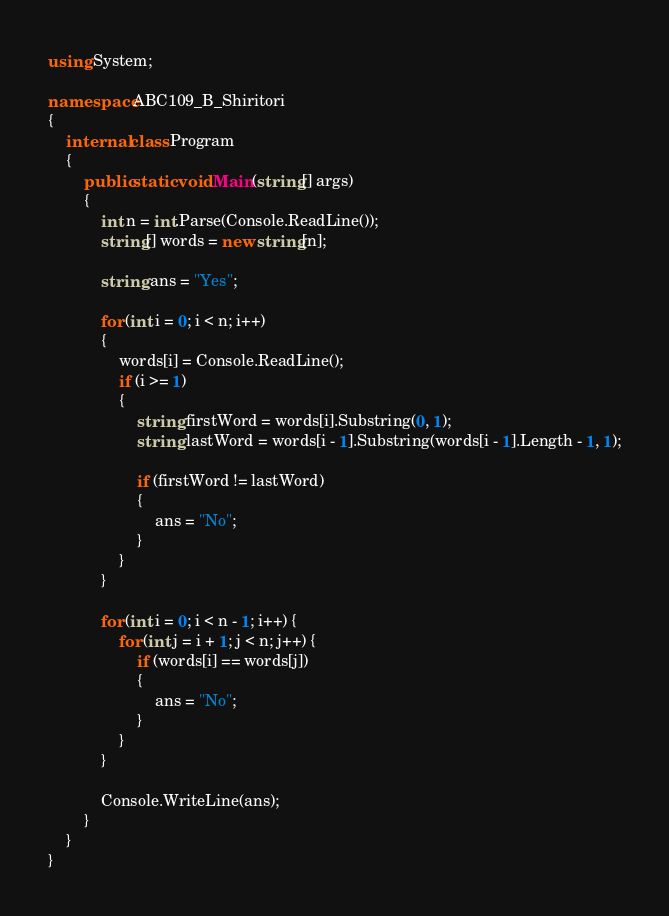<code> <loc_0><loc_0><loc_500><loc_500><_C#_>using System;

namespace ABC109_B_Shiritori
{
	internal class Program
	{
		public static void Main(string[] args)
		{
			int n = int.Parse(Console.ReadLine());
			string[] words = new string[n];

			string ans = "Yes";

			for (int i = 0; i < n; i++)
			{
				words[i] = Console.ReadLine();
				if (i >= 1)
				{
					string firstWord = words[i].Substring(0, 1);
					string lastWord = words[i - 1].Substring(words[i - 1].Length - 1, 1);

					if (firstWord != lastWord)
					{
						ans = "No";
					}
				}
			}

			for (int i = 0; i < n - 1; i++) {
				for (int j = i + 1; j < n; j++) {
					if (words[i] == words[j])
					{
						ans = "No";
					}
				}
			}

			Console.WriteLine(ans);
		}
	}
}</code> 